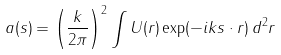<formula> <loc_0><loc_0><loc_500><loc_500>a ( s ) = \left ( \frac { k } { 2 \pi } \right ) ^ { 2 } \int U ( r ) \exp ( - i k s \cdot r ) \, d ^ { 2 } r</formula> 